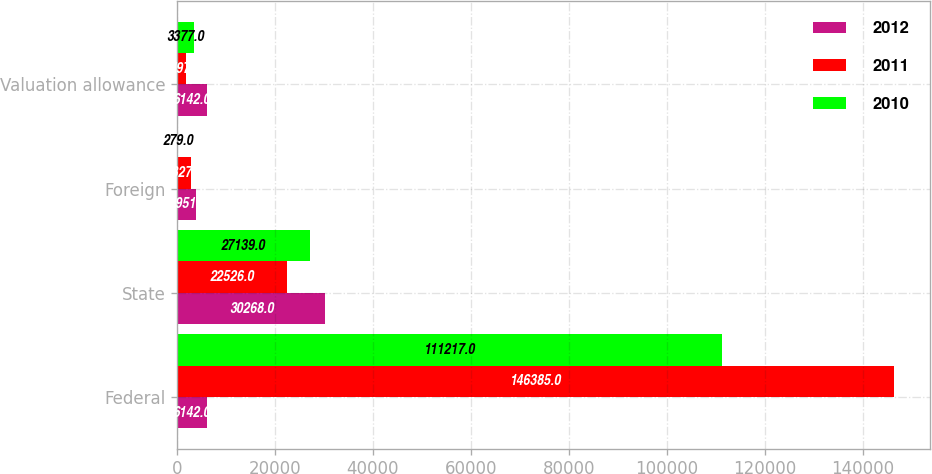<chart> <loc_0><loc_0><loc_500><loc_500><stacked_bar_chart><ecel><fcel>Federal<fcel>State<fcel>Foreign<fcel>Valuation allowance<nl><fcel>2012<fcel>6142<fcel>30268<fcel>3951<fcel>6142<nl><fcel>2011<fcel>146385<fcel>22526<fcel>2827<fcel>1797<nl><fcel>2010<fcel>111217<fcel>27139<fcel>279<fcel>3377<nl></chart> 